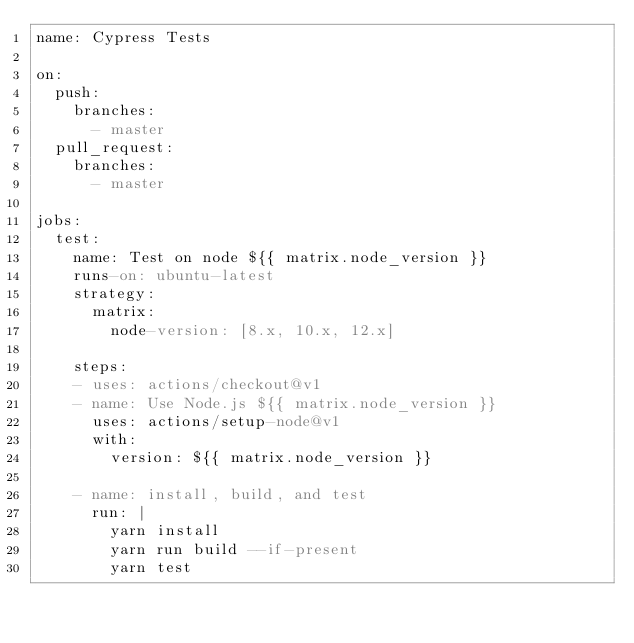<code> <loc_0><loc_0><loc_500><loc_500><_YAML_>name: Cypress Tests

on:
  push:
    branches: 
      - master
  pull_request:
    branches: 
      - master

jobs:
  test:
    name: Test on node ${{ matrix.node_version }}
    runs-on: ubuntu-latest
    strategy:
      matrix:
        node-version: [8.x, 10.x, 12.x]
    
    steps:
    - uses: actions/checkout@v1
    - name: Use Node.js ${{ matrix.node_version }}
      uses: actions/setup-node@v1
      with:
        version: ${{ matrix.node_version }}
    
    - name: install, build, and test
      run: |
        yarn install
        yarn run build --if-present
        yarn test
</code> 